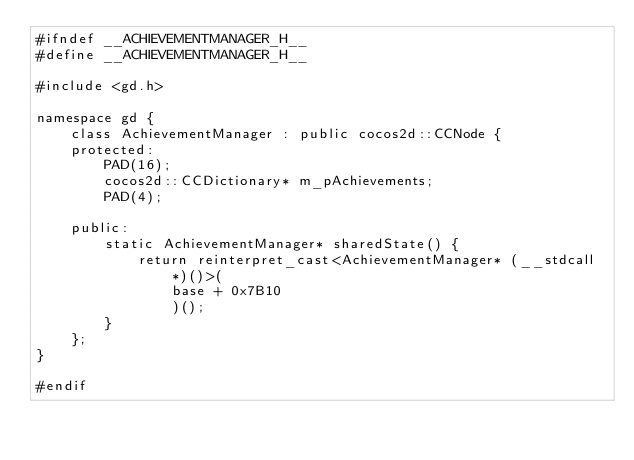Convert code to text. <code><loc_0><loc_0><loc_500><loc_500><_C_>#ifndef __ACHIEVEMENTMANAGER_H__
#define __ACHIEVEMENTMANAGER_H__

#include <gd.h>

namespace gd {
	class AchievementManager : public cocos2d::CCNode {
	protected:
		PAD(16);
		cocos2d::CCDictionary* m_pAchievements;
		PAD(4);

	public:
		static AchievementManager* sharedState() {
			return reinterpret_cast<AchievementManager* (__stdcall*)()>(
				base + 0x7B10
				)();
		}
	};
}

#endif</code> 